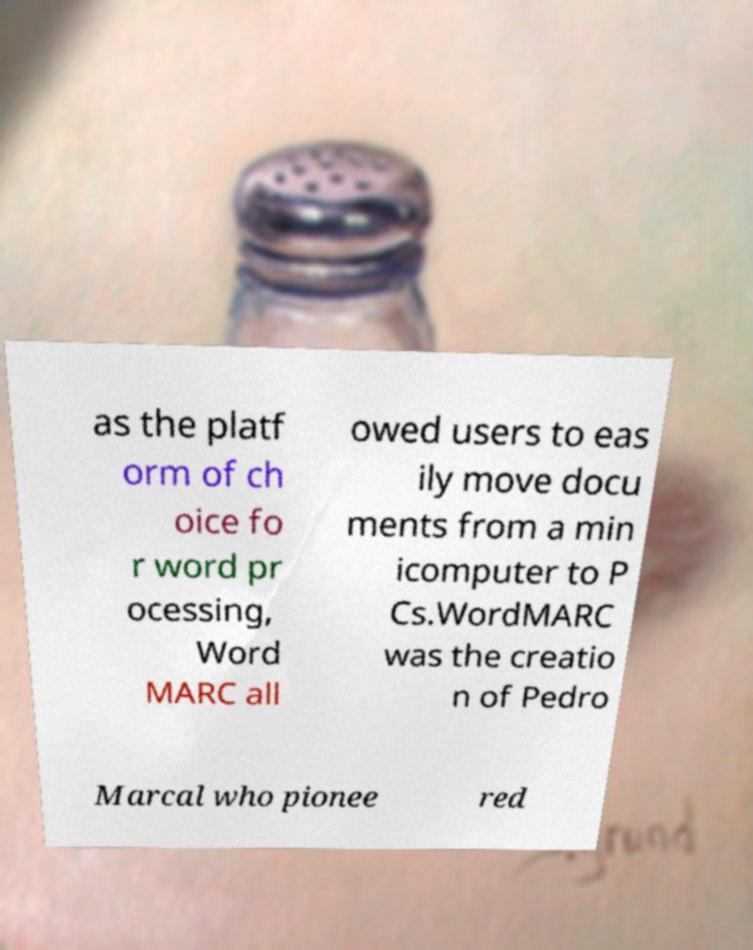Can you read and provide the text displayed in the image?This photo seems to have some interesting text. Can you extract and type it out for me? as the platf orm of ch oice fo r word pr ocessing, Word MARC all owed users to eas ily move docu ments from a min icomputer to P Cs.WordMARC was the creatio n of Pedro Marcal who pionee red 